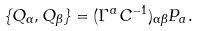<formula> <loc_0><loc_0><loc_500><loc_500>\{ Q _ { \alpha } , Q _ { \beta } \} = ( \Gamma ^ { a } C ^ { - 1 } ) _ { \alpha \beta } P _ { a } .</formula> 